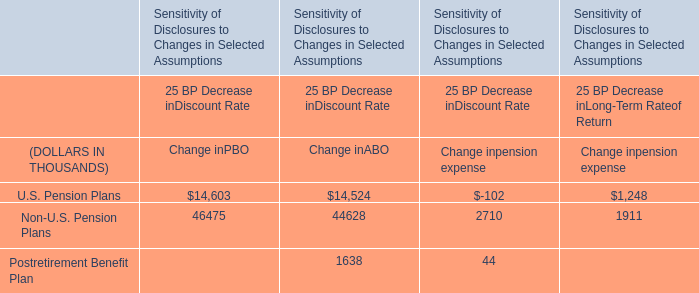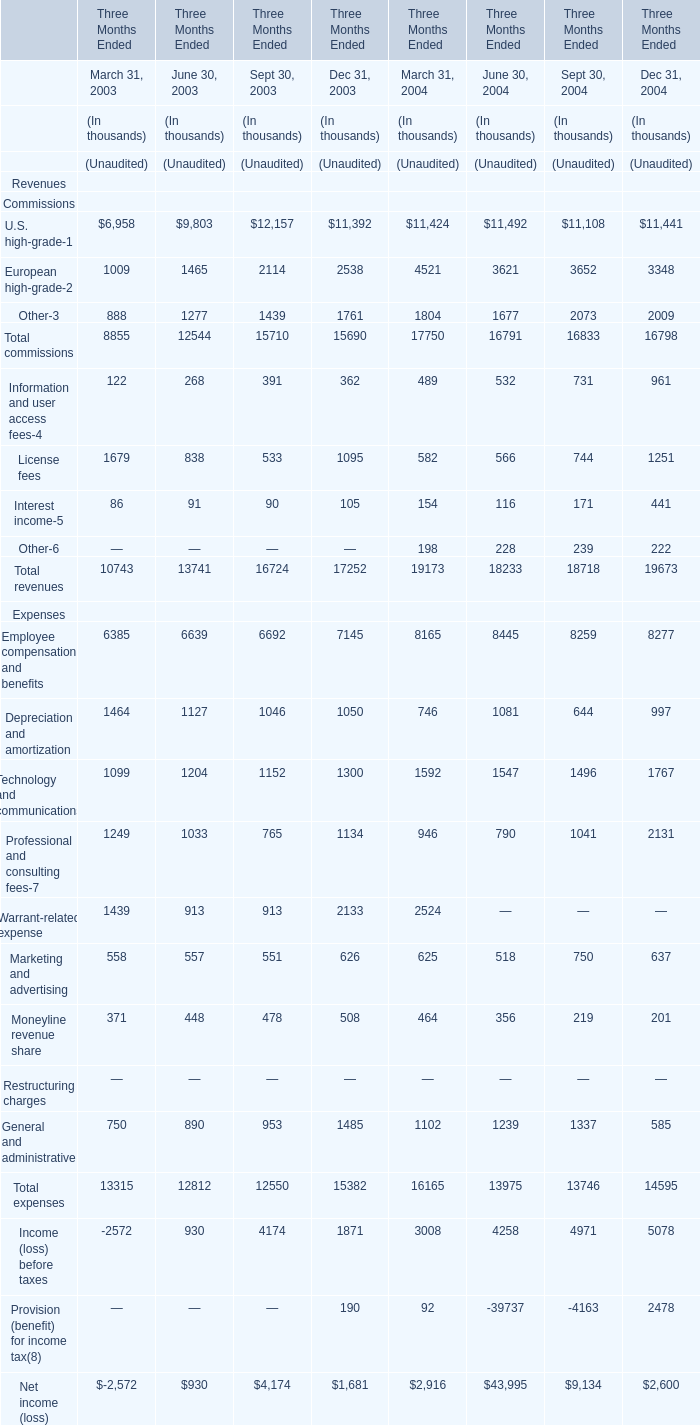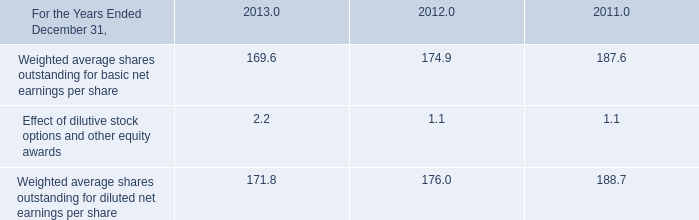What is the growing rate of Total commissions in the years with the least March 31, 2003? 
Computations: ((8855 - 12544) / 8855)
Answer: -0.4166. 